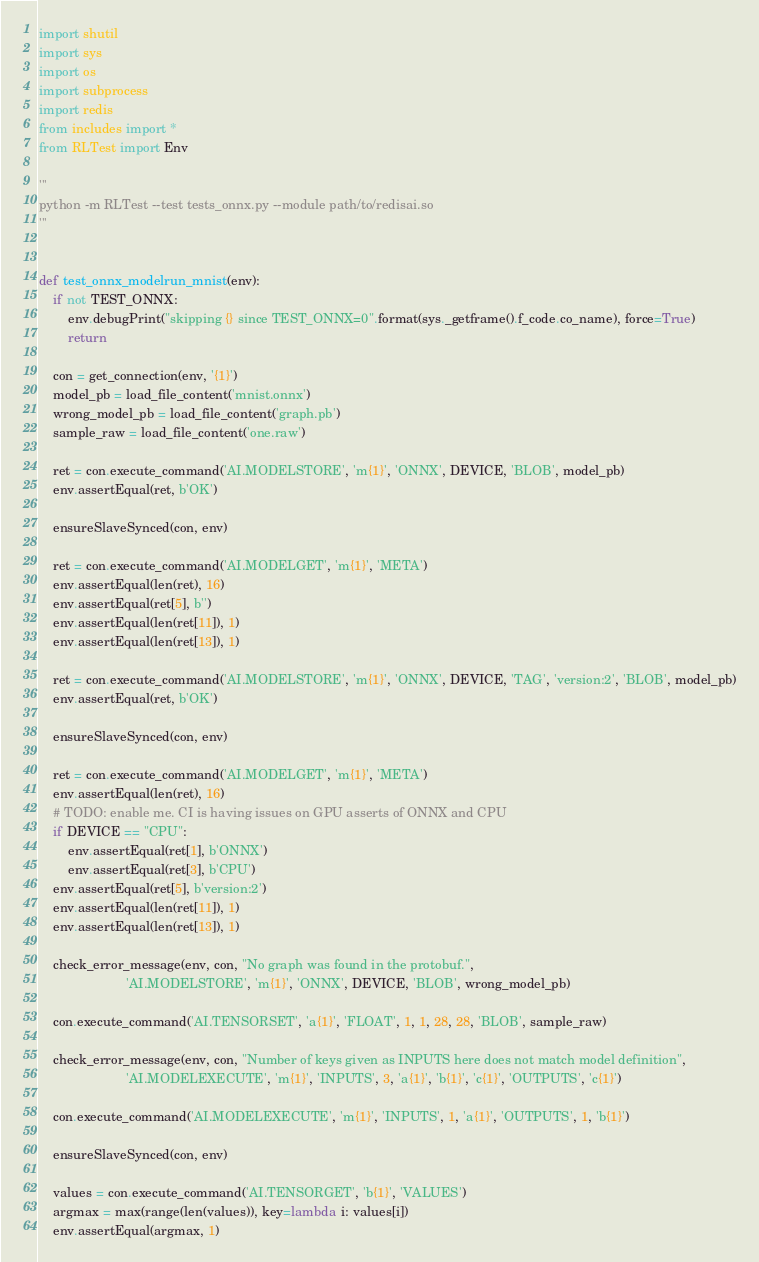<code> <loc_0><loc_0><loc_500><loc_500><_Python_>import shutil
import sys
import os
import subprocess
import redis
from includes import *
from RLTest import Env

'''
python -m RLTest --test tests_onnx.py --module path/to/redisai.so
'''


def test_onnx_modelrun_mnist(env):
    if not TEST_ONNX:
        env.debugPrint("skipping {} since TEST_ONNX=0".format(sys._getframe().f_code.co_name), force=True)
        return

    con = get_connection(env, '{1}')
    model_pb = load_file_content('mnist.onnx')
    wrong_model_pb = load_file_content('graph.pb')
    sample_raw = load_file_content('one.raw')

    ret = con.execute_command('AI.MODELSTORE', 'm{1}', 'ONNX', DEVICE, 'BLOB', model_pb)
    env.assertEqual(ret, b'OK')

    ensureSlaveSynced(con, env)

    ret = con.execute_command('AI.MODELGET', 'm{1}', 'META')
    env.assertEqual(len(ret), 16)
    env.assertEqual(ret[5], b'')
    env.assertEqual(len(ret[11]), 1)
    env.assertEqual(len(ret[13]), 1)

    ret = con.execute_command('AI.MODELSTORE', 'm{1}', 'ONNX', DEVICE, 'TAG', 'version:2', 'BLOB', model_pb)
    env.assertEqual(ret, b'OK')

    ensureSlaveSynced(con, env)

    ret = con.execute_command('AI.MODELGET', 'm{1}', 'META')
    env.assertEqual(len(ret), 16)
    # TODO: enable me. CI is having issues on GPU asserts of ONNX and CPU
    if DEVICE == "CPU":
        env.assertEqual(ret[1], b'ONNX')
        env.assertEqual(ret[3], b'CPU')
    env.assertEqual(ret[5], b'version:2')
    env.assertEqual(len(ret[11]), 1)
    env.assertEqual(len(ret[13]), 1)

    check_error_message(env, con, "No graph was found in the protobuf.",
                        'AI.MODELSTORE', 'm{1}', 'ONNX', DEVICE, 'BLOB', wrong_model_pb)

    con.execute_command('AI.TENSORSET', 'a{1}', 'FLOAT', 1, 1, 28, 28, 'BLOB', sample_raw)

    check_error_message(env, con, "Number of keys given as INPUTS here does not match model definition",
                        'AI.MODELEXECUTE', 'm{1}', 'INPUTS', 3, 'a{1}', 'b{1}', 'c{1}', 'OUTPUTS', 'c{1}')

    con.execute_command('AI.MODELEXECUTE', 'm{1}', 'INPUTS', 1, 'a{1}', 'OUTPUTS', 1, 'b{1}')

    ensureSlaveSynced(con, env)

    values = con.execute_command('AI.TENSORGET', 'b{1}', 'VALUES')
    argmax = max(range(len(values)), key=lambda i: values[i])
    env.assertEqual(argmax, 1)
</code> 